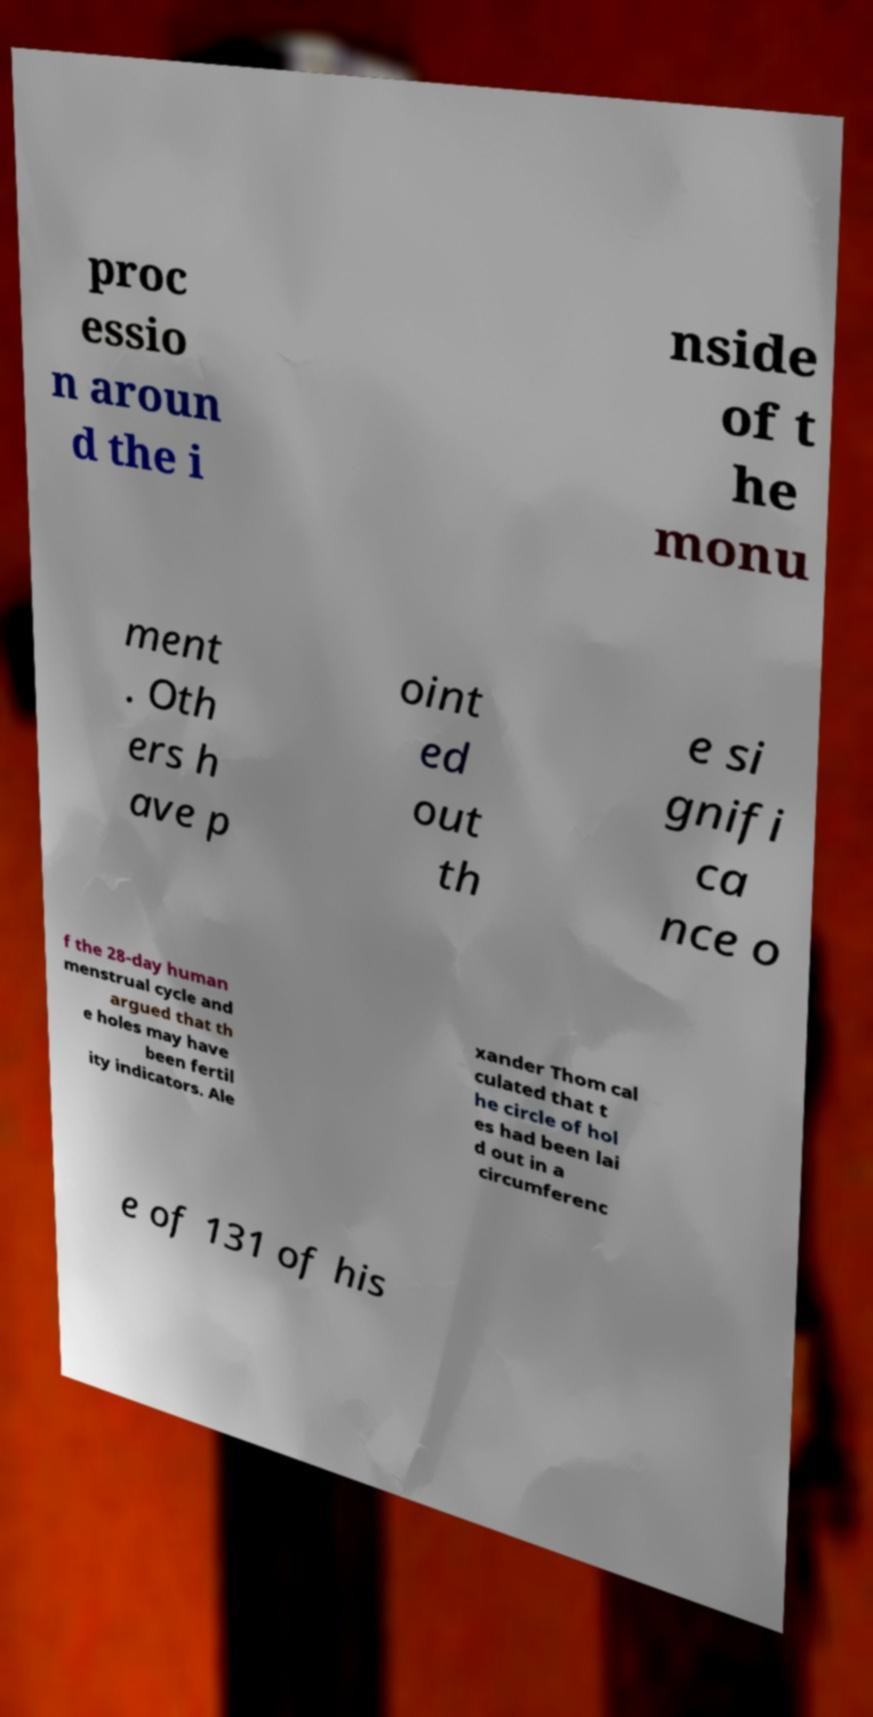Please read and relay the text visible in this image. What does it say? proc essio n aroun d the i nside of t he monu ment . Oth ers h ave p oint ed out th e si gnifi ca nce o f the 28-day human menstrual cycle and argued that th e holes may have been fertil ity indicators. Ale xander Thom cal culated that t he circle of hol es had been lai d out in a circumferenc e of 131 of his 